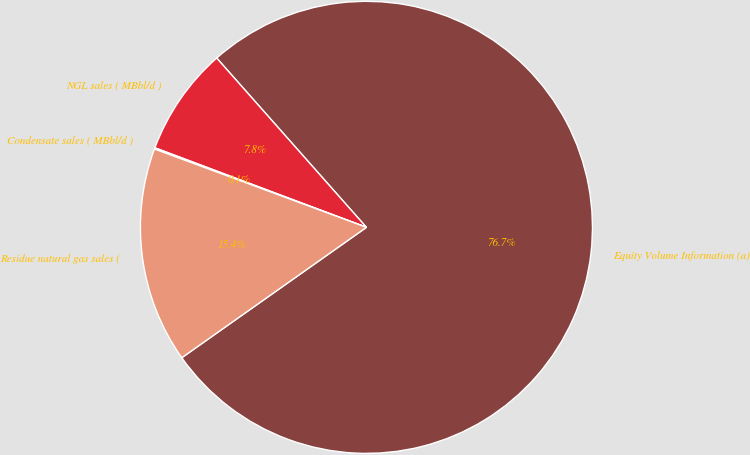Convert chart to OTSL. <chart><loc_0><loc_0><loc_500><loc_500><pie_chart><fcel>Equity Volume Information (a)<fcel>NGL sales ( MBbl/d )<fcel>Condensate sales ( MBbl/d )<fcel>Residue natural gas sales (<nl><fcel>76.74%<fcel>7.75%<fcel>0.09%<fcel>15.42%<nl></chart> 